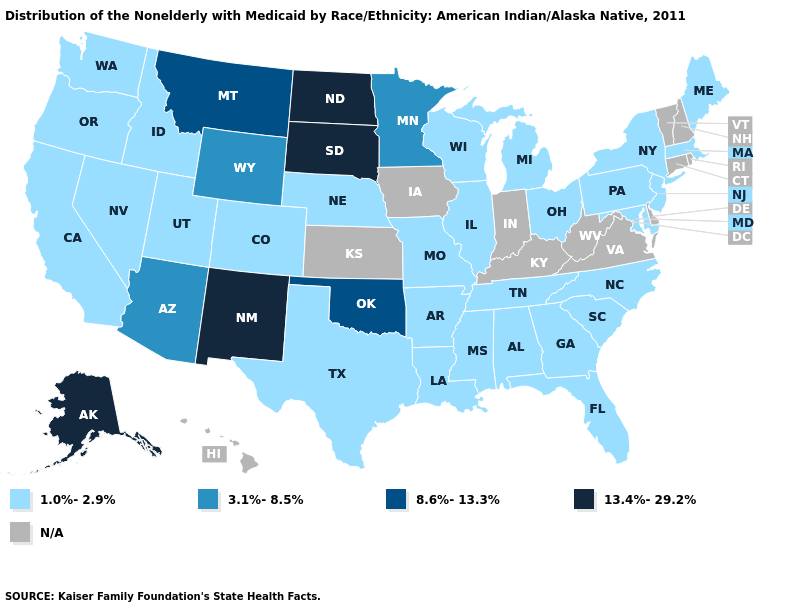What is the value of Colorado?
Quick response, please. 1.0%-2.9%. What is the value of Texas?
Concise answer only. 1.0%-2.9%. Name the states that have a value in the range 3.1%-8.5%?
Give a very brief answer. Arizona, Minnesota, Wyoming. Name the states that have a value in the range 8.6%-13.3%?
Quick response, please. Montana, Oklahoma. Does the map have missing data?
Keep it brief. Yes. Does New Mexico have the highest value in the USA?
Keep it brief. Yes. Which states hav the highest value in the Northeast?
Give a very brief answer. Maine, Massachusetts, New Jersey, New York, Pennsylvania. Which states have the highest value in the USA?
Write a very short answer. Alaska, New Mexico, North Dakota, South Dakota. Among the states that border Delaware , which have the highest value?
Write a very short answer. Maryland, New Jersey, Pennsylvania. What is the highest value in the USA?
Write a very short answer. 13.4%-29.2%. What is the value of Mississippi?
Quick response, please. 1.0%-2.9%. Does Texas have the lowest value in the USA?
Short answer required. Yes. Does Oklahoma have the lowest value in the South?
Concise answer only. No. 